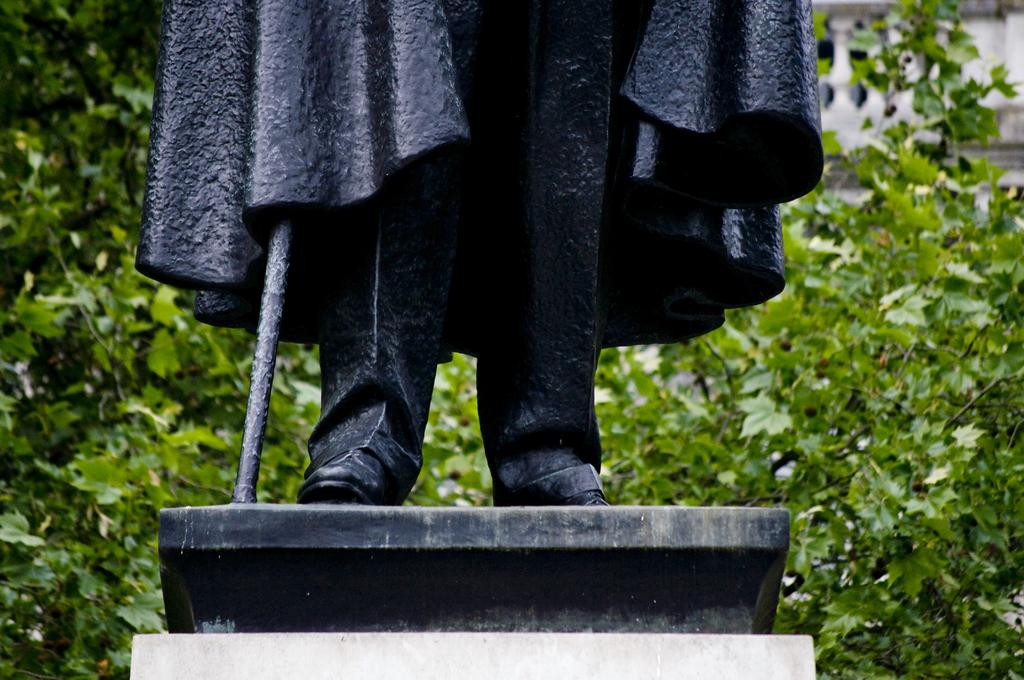What is the main subject of the image? There is a statue of a person in the image. Where is the statue located? The statue is on a pillar. What can be seen in the background of the image? There are trees in the background of the image. What type of cactus can be seen growing near the statue in the image? There is no cactus present in the image. 